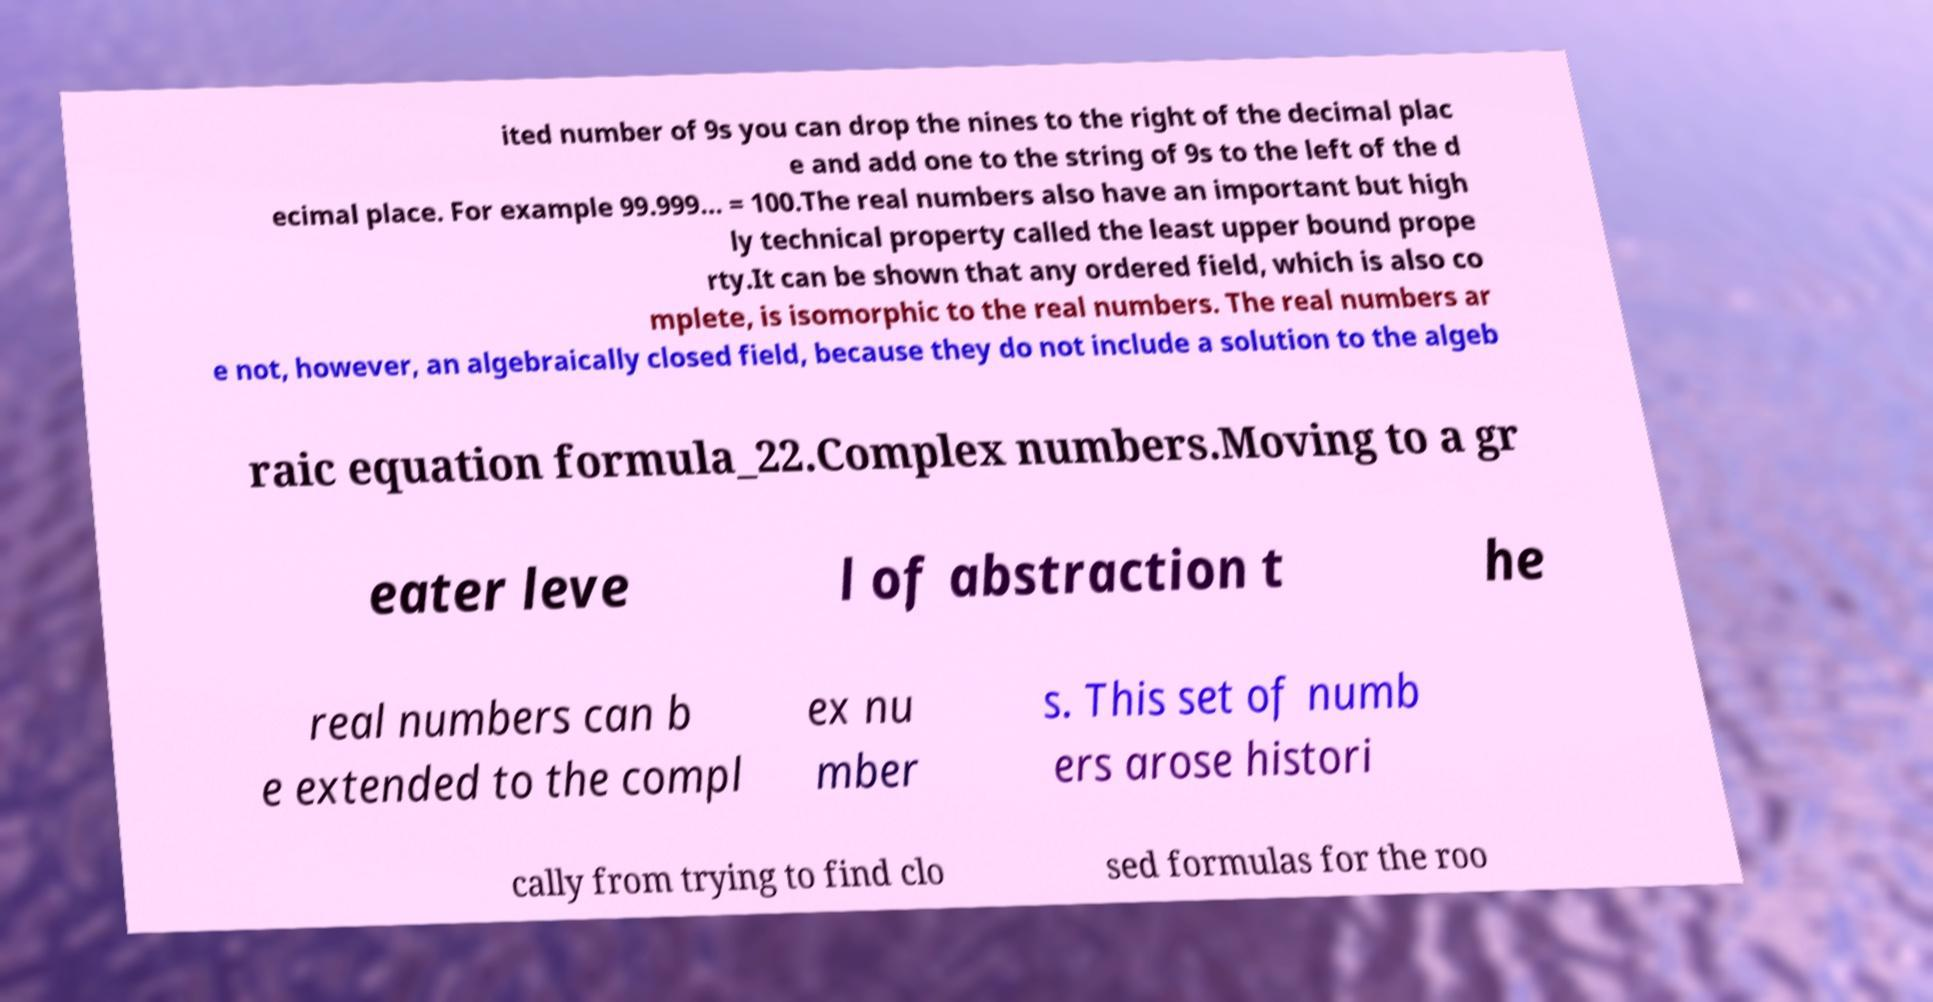There's text embedded in this image that I need extracted. Can you transcribe it verbatim? ited number of 9s you can drop the nines to the right of the decimal plac e and add one to the string of 9s to the left of the d ecimal place. For example 99.999... = 100.The real numbers also have an important but high ly technical property called the least upper bound prope rty.It can be shown that any ordered field, which is also co mplete, is isomorphic to the real numbers. The real numbers ar e not, however, an algebraically closed field, because they do not include a solution to the algeb raic equation formula_22.Complex numbers.Moving to a gr eater leve l of abstraction t he real numbers can b e extended to the compl ex nu mber s. This set of numb ers arose histori cally from trying to find clo sed formulas for the roo 